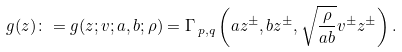<formula> <loc_0><loc_0><loc_500><loc_500>g ( z ) \colon = g ( z ; v ; a , b ; \rho ) = \Gamma _ { \, p , q } \left ( a z ^ { \pm } , b z ^ { \pm } , \sqrt { \frac { \rho } { a b } } v ^ { \pm } z ^ { \pm } \right ) .</formula> 